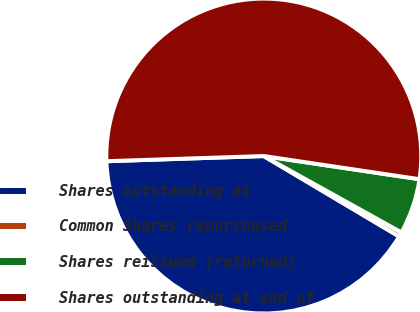<chart> <loc_0><loc_0><loc_500><loc_500><pie_chart><fcel>Shares outstanding at<fcel>Common Shares repurchased<fcel>Shares reissued (returned)<fcel>Shares outstanding at end of<nl><fcel>40.94%<fcel>0.47%<fcel>5.71%<fcel>52.87%<nl></chart> 